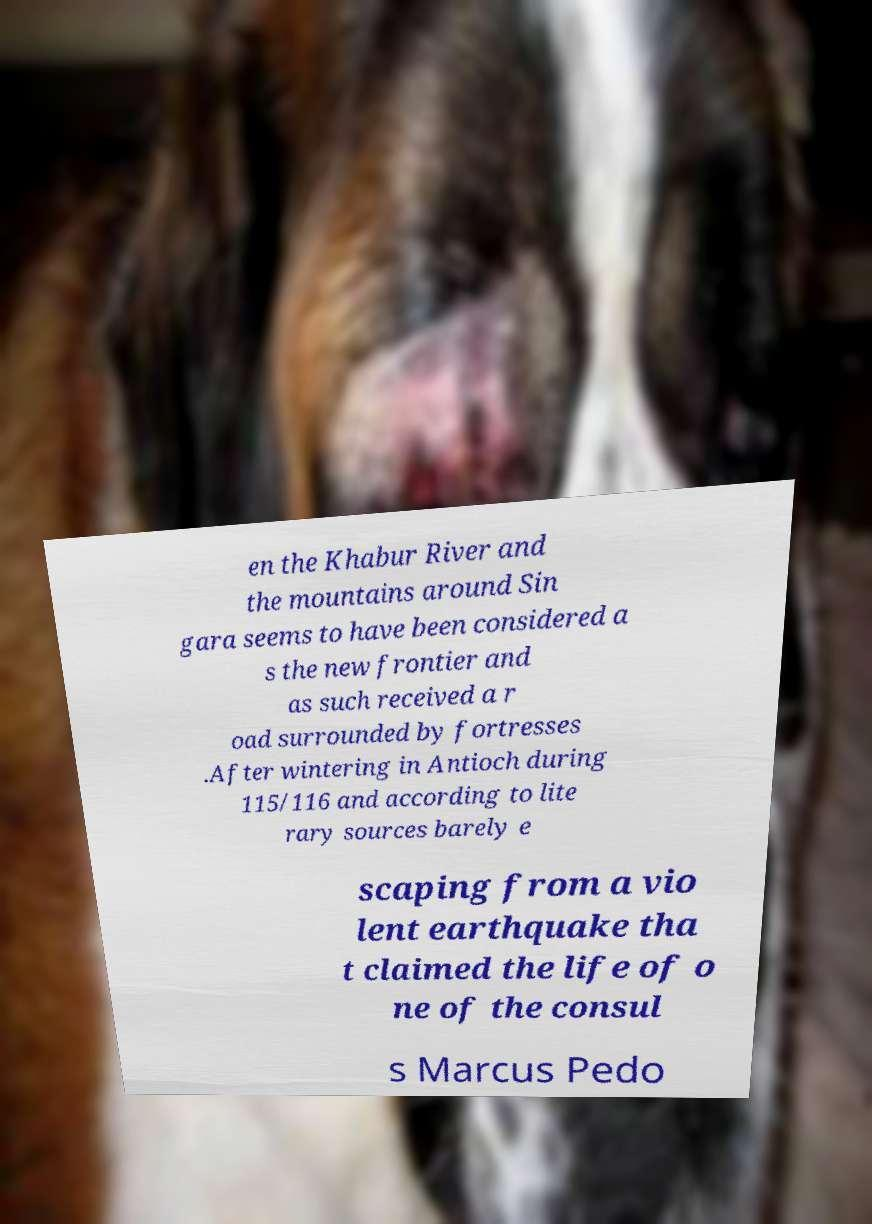Please identify and transcribe the text found in this image. en the Khabur River and the mountains around Sin gara seems to have been considered a s the new frontier and as such received a r oad surrounded by fortresses .After wintering in Antioch during 115/116 and according to lite rary sources barely e scaping from a vio lent earthquake tha t claimed the life of o ne of the consul s Marcus Pedo 